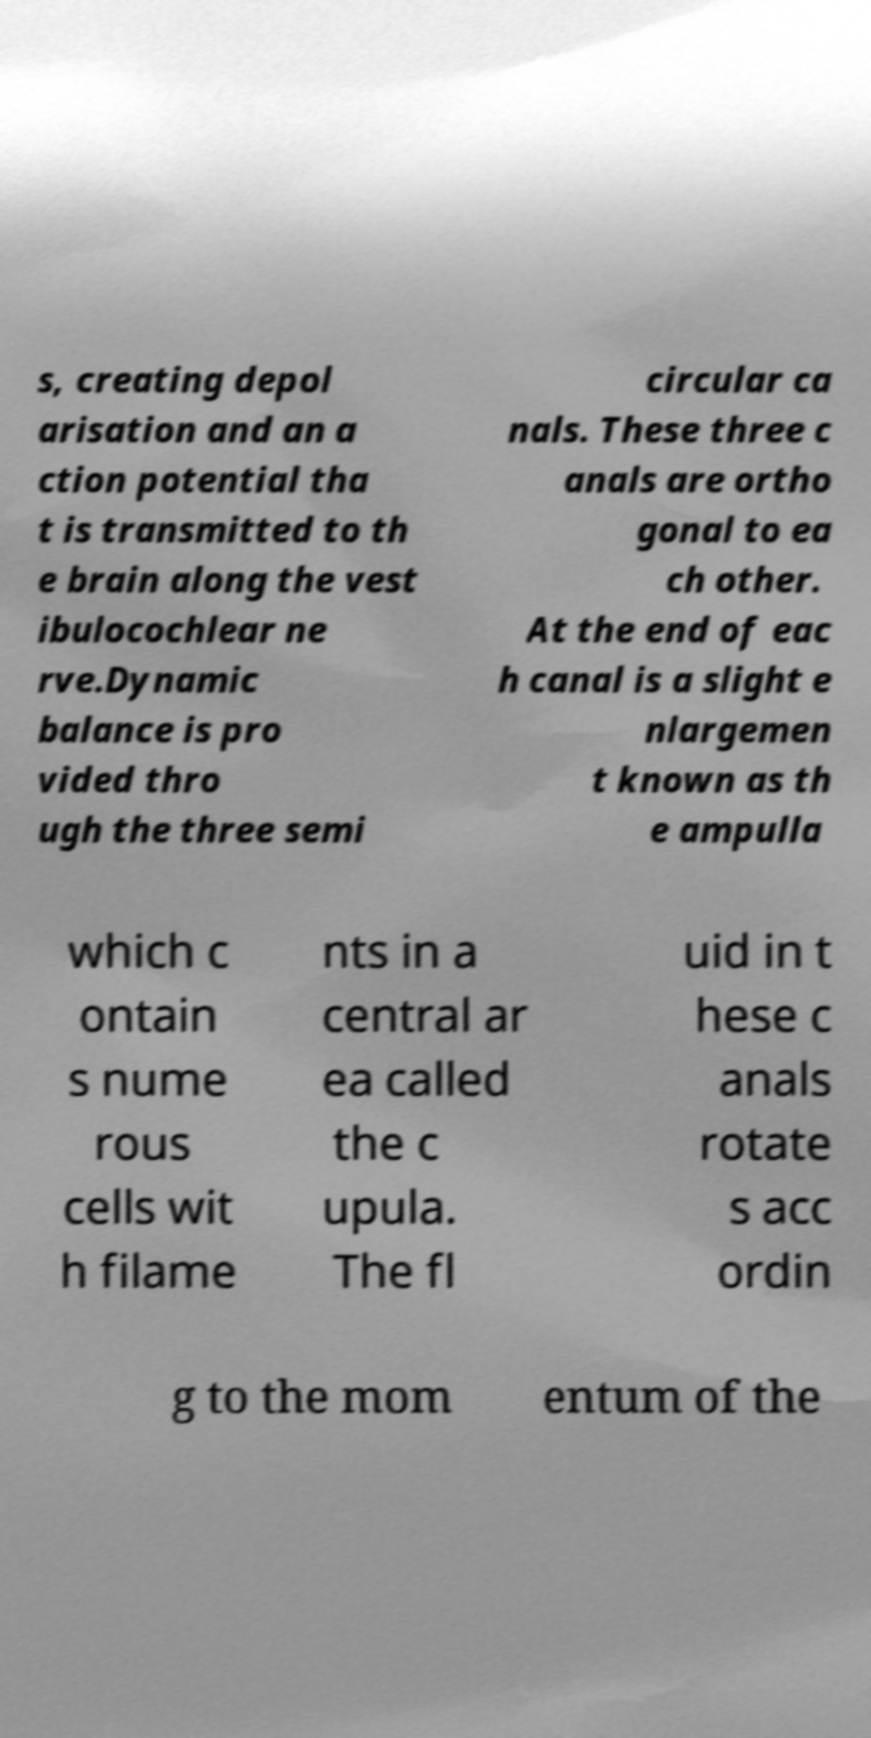Could you assist in decoding the text presented in this image and type it out clearly? s, creating depol arisation and an a ction potential tha t is transmitted to th e brain along the vest ibulocochlear ne rve.Dynamic balance is pro vided thro ugh the three semi circular ca nals. These three c anals are ortho gonal to ea ch other. At the end of eac h canal is a slight e nlargemen t known as th e ampulla which c ontain s nume rous cells wit h filame nts in a central ar ea called the c upula. The fl uid in t hese c anals rotate s acc ordin g to the mom entum of the 